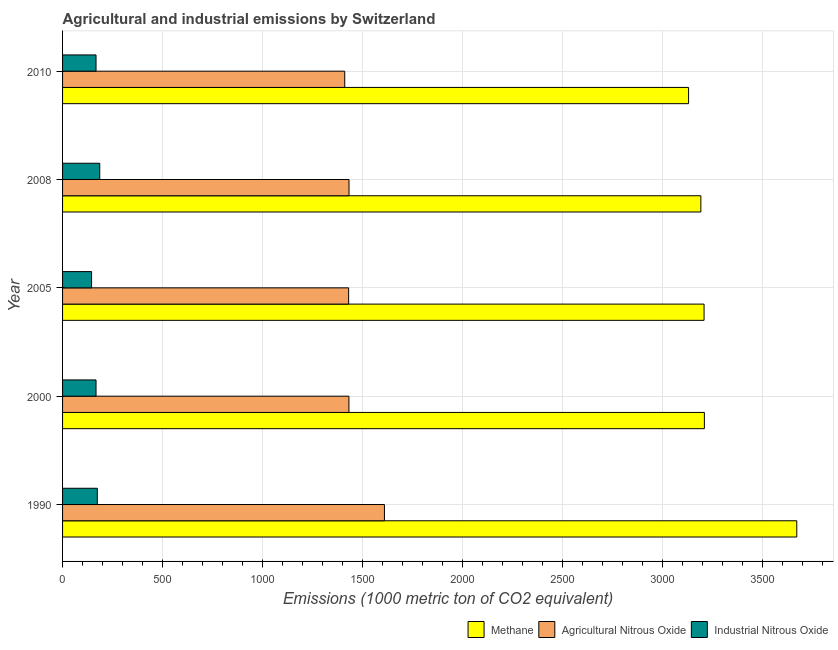How many groups of bars are there?
Keep it short and to the point. 5. How many bars are there on the 4th tick from the top?
Provide a succinct answer. 3. How many bars are there on the 3rd tick from the bottom?
Ensure brevity in your answer.  3. In how many cases, is the number of bars for a given year not equal to the number of legend labels?
Offer a terse response. 0. What is the amount of methane emissions in 2005?
Make the answer very short. 3209.2. Across all years, what is the maximum amount of agricultural nitrous oxide emissions?
Your answer should be very brief. 1610.2. Across all years, what is the minimum amount of methane emissions?
Give a very brief answer. 3131.7. What is the total amount of methane emissions in the graph?
Your answer should be compact. 1.64e+04. What is the difference between the amount of industrial nitrous oxide emissions in 1990 and that in 2005?
Provide a succinct answer. 28.7. What is the difference between the amount of methane emissions in 2000 and the amount of industrial nitrous oxide emissions in 2008?
Give a very brief answer. 3024.7. What is the average amount of industrial nitrous oxide emissions per year?
Keep it short and to the point. 167.94. In the year 2000, what is the difference between the amount of agricultural nitrous oxide emissions and amount of methane emissions?
Keep it short and to the point. -1778.2. Is the amount of methane emissions in 2005 less than that in 2010?
Offer a terse response. No. What is the difference between the highest and the second highest amount of methane emissions?
Your answer should be compact. 462.3. What is the difference between the highest and the lowest amount of agricultural nitrous oxide emissions?
Provide a short and direct response. 198.6. What does the 2nd bar from the top in 2005 represents?
Give a very brief answer. Agricultural Nitrous Oxide. What does the 2nd bar from the bottom in 2005 represents?
Ensure brevity in your answer.  Agricultural Nitrous Oxide. Is it the case that in every year, the sum of the amount of methane emissions and amount of agricultural nitrous oxide emissions is greater than the amount of industrial nitrous oxide emissions?
Ensure brevity in your answer.  Yes. How many bars are there?
Your response must be concise. 15. Are all the bars in the graph horizontal?
Keep it short and to the point. Yes. What is the difference between two consecutive major ticks on the X-axis?
Offer a very short reply. 500. Are the values on the major ticks of X-axis written in scientific E-notation?
Offer a very short reply. No. Where does the legend appear in the graph?
Ensure brevity in your answer.  Bottom right. How many legend labels are there?
Make the answer very short. 3. What is the title of the graph?
Offer a terse response. Agricultural and industrial emissions by Switzerland. What is the label or title of the X-axis?
Keep it short and to the point. Emissions (1000 metric ton of CO2 equivalent). What is the Emissions (1000 metric ton of CO2 equivalent) in Methane in 1990?
Your answer should be compact. 3673. What is the Emissions (1000 metric ton of CO2 equivalent) in Agricultural Nitrous Oxide in 1990?
Ensure brevity in your answer.  1610.2. What is the Emissions (1000 metric ton of CO2 equivalent) in Industrial Nitrous Oxide in 1990?
Give a very brief answer. 173.8. What is the Emissions (1000 metric ton of CO2 equivalent) in Methane in 2000?
Make the answer very short. 3210.7. What is the Emissions (1000 metric ton of CO2 equivalent) of Agricultural Nitrous Oxide in 2000?
Give a very brief answer. 1432.5. What is the Emissions (1000 metric ton of CO2 equivalent) of Industrial Nitrous Oxide in 2000?
Provide a succinct answer. 167.4. What is the Emissions (1000 metric ton of CO2 equivalent) of Methane in 2005?
Ensure brevity in your answer.  3209.2. What is the Emissions (1000 metric ton of CO2 equivalent) in Agricultural Nitrous Oxide in 2005?
Provide a succinct answer. 1431.1. What is the Emissions (1000 metric ton of CO2 equivalent) in Industrial Nitrous Oxide in 2005?
Offer a terse response. 145.1. What is the Emissions (1000 metric ton of CO2 equivalent) of Methane in 2008?
Make the answer very short. 3193.1. What is the Emissions (1000 metric ton of CO2 equivalent) in Agricultural Nitrous Oxide in 2008?
Your answer should be very brief. 1433. What is the Emissions (1000 metric ton of CO2 equivalent) of Industrial Nitrous Oxide in 2008?
Your answer should be compact. 186. What is the Emissions (1000 metric ton of CO2 equivalent) in Methane in 2010?
Your answer should be very brief. 3131.7. What is the Emissions (1000 metric ton of CO2 equivalent) in Agricultural Nitrous Oxide in 2010?
Your response must be concise. 1411.6. What is the Emissions (1000 metric ton of CO2 equivalent) in Industrial Nitrous Oxide in 2010?
Provide a short and direct response. 167.4. Across all years, what is the maximum Emissions (1000 metric ton of CO2 equivalent) of Methane?
Offer a very short reply. 3673. Across all years, what is the maximum Emissions (1000 metric ton of CO2 equivalent) in Agricultural Nitrous Oxide?
Keep it short and to the point. 1610.2. Across all years, what is the maximum Emissions (1000 metric ton of CO2 equivalent) of Industrial Nitrous Oxide?
Your answer should be very brief. 186. Across all years, what is the minimum Emissions (1000 metric ton of CO2 equivalent) of Methane?
Offer a very short reply. 3131.7. Across all years, what is the minimum Emissions (1000 metric ton of CO2 equivalent) of Agricultural Nitrous Oxide?
Provide a succinct answer. 1411.6. Across all years, what is the minimum Emissions (1000 metric ton of CO2 equivalent) in Industrial Nitrous Oxide?
Your answer should be compact. 145.1. What is the total Emissions (1000 metric ton of CO2 equivalent) in Methane in the graph?
Keep it short and to the point. 1.64e+04. What is the total Emissions (1000 metric ton of CO2 equivalent) in Agricultural Nitrous Oxide in the graph?
Your answer should be very brief. 7318.4. What is the total Emissions (1000 metric ton of CO2 equivalent) of Industrial Nitrous Oxide in the graph?
Ensure brevity in your answer.  839.7. What is the difference between the Emissions (1000 metric ton of CO2 equivalent) of Methane in 1990 and that in 2000?
Make the answer very short. 462.3. What is the difference between the Emissions (1000 metric ton of CO2 equivalent) in Agricultural Nitrous Oxide in 1990 and that in 2000?
Your answer should be very brief. 177.7. What is the difference between the Emissions (1000 metric ton of CO2 equivalent) of Methane in 1990 and that in 2005?
Ensure brevity in your answer.  463.8. What is the difference between the Emissions (1000 metric ton of CO2 equivalent) in Agricultural Nitrous Oxide in 1990 and that in 2005?
Provide a succinct answer. 179.1. What is the difference between the Emissions (1000 metric ton of CO2 equivalent) of Industrial Nitrous Oxide in 1990 and that in 2005?
Your answer should be very brief. 28.7. What is the difference between the Emissions (1000 metric ton of CO2 equivalent) of Methane in 1990 and that in 2008?
Ensure brevity in your answer.  479.9. What is the difference between the Emissions (1000 metric ton of CO2 equivalent) of Agricultural Nitrous Oxide in 1990 and that in 2008?
Your answer should be compact. 177.2. What is the difference between the Emissions (1000 metric ton of CO2 equivalent) of Industrial Nitrous Oxide in 1990 and that in 2008?
Ensure brevity in your answer.  -12.2. What is the difference between the Emissions (1000 metric ton of CO2 equivalent) of Methane in 1990 and that in 2010?
Your answer should be very brief. 541.3. What is the difference between the Emissions (1000 metric ton of CO2 equivalent) of Agricultural Nitrous Oxide in 1990 and that in 2010?
Your response must be concise. 198.6. What is the difference between the Emissions (1000 metric ton of CO2 equivalent) of Methane in 2000 and that in 2005?
Ensure brevity in your answer.  1.5. What is the difference between the Emissions (1000 metric ton of CO2 equivalent) in Agricultural Nitrous Oxide in 2000 and that in 2005?
Keep it short and to the point. 1.4. What is the difference between the Emissions (1000 metric ton of CO2 equivalent) in Industrial Nitrous Oxide in 2000 and that in 2005?
Provide a succinct answer. 22.3. What is the difference between the Emissions (1000 metric ton of CO2 equivalent) of Methane in 2000 and that in 2008?
Your answer should be very brief. 17.6. What is the difference between the Emissions (1000 metric ton of CO2 equivalent) in Agricultural Nitrous Oxide in 2000 and that in 2008?
Keep it short and to the point. -0.5. What is the difference between the Emissions (1000 metric ton of CO2 equivalent) of Industrial Nitrous Oxide in 2000 and that in 2008?
Ensure brevity in your answer.  -18.6. What is the difference between the Emissions (1000 metric ton of CO2 equivalent) in Methane in 2000 and that in 2010?
Offer a terse response. 79. What is the difference between the Emissions (1000 metric ton of CO2 equivalent) in Agricultural Nitrous Oxide in 2000 and that in 2010?
Your response must be concise. 20.9. What is the difference between the Emissions (1000 metric ton of CO2 equivalent) in Industrial Nitrous Oxide in 2000 and that in 2010?
Give a very brief answer. 0. What is the difference between the Emissions (1000 metric ton of CO2 equivalent) of Industrial Nitrous Oxide in 2005 and that in 2008?
Ensure brevity in your answer.  -40.9. What is the difference between the Emissions (1000 metric ton of CO2 equivalent) of Methane in 2005 and that in 2010?
Keep it short and to the point. 77.5. What is the difference between the Emissions (1000 metric ton of CO2 equivalent) of Industrial Nitrous Oxide in 2005 and that in 2010?
Keep it short and to the point. -22.3. What is the difference between the Emissions (1000 metric ton of CO2 equivalent) of Methane in 2008 and that in 2010?
Make the answer very short. 61.4. What is the difference between the Emissions (1000 metric ton of CO2 equivalent) in Agricultural Nitrous Oxide in 2008 and that in 2010?
Ensure brevity in your answer.  21.4. What is the difference between the Emissions (1000 metric ton of CO2 equivalent) in Methane in 1990 and the Emissions (1000 metric ton of CO2 equivalent) in Agricultural Nitrous Oxide in 2000?
Your response must be concise. 2240.5. What is the difference between the Emissions (1000 metric ton of CO2 equivalent) of Methane in 1990 and the Emissions (1000 metric ton of CO2 equivalent) of Industrial Nitrous Oxide in 2000?
Ensure brevity in your answer.  3505.6. What is the difference between the Emissions (1000 metric ton of CO2 equivalent) in Agricultural Nitrous Oxide in 1990 and the Emissions (1000 metric ton of CO2 equivalent) in Industrial Nitrous Oxide in 2000?
Provide a short and direct response. 1442.8. What is the difference between the Emissions (1000 metric ton of CO2 equivalent) of Methane in 1990 and the Emissions (1000 metric ton of CO2 equivalent) of Agricultural Nitrous Oxide in 2005?
Offer a terse response. 2241.9. What is the difference between the Emissions (1000 metric ton of CO2 equivalent) in Methane in 1990 and the Emissions (1000 metric ton of CO2 equivalent) in Industrial Nitrous Oxide in 2005?
Your answer should be compact. 3527.9. What is the difference between the Emissions (1000 metric ton of CO2 equivalent) of Agricultural Nitrous Oxide in 1990 and the Emissions (1000 metric ton of CO2 equivalent) of Industrial Nitrous Oxide in 2005?
Offer a terse response. 1465.1. What is the difference between the Emissions (1000 metric ton of CO2 equivalent) in Methane in 1990 and the Emissions (1000 metric ton of CO2 equivalent) in Agricultural Nitrous Oxide in 2008?
Give a very brief answer. 2240. What is the difference between the Emissions (1000 metric ton of CO2 equivalent) of Methane in 1990 and the Emissions (1000 metric ton of CO2 equivalent) of Industrial Nitrous Oxide in 2008?
Offer a terse response. 3487. What is the difference between the Emissions (1000 metric ton of CO2 equivalent) in Agricultural Nitrous Oxide in 1990 and the Emissions (1000 metric ton of CO2 equivalent) in Industrial Nitrous Oxide in 2008?
Provide a short and direct response. 1424.2. What is the difference between the Emissions (1000 metric ton of CO2 equivalent) of Methane in 1990 and the Emissions (1000 metric ton of CO2 equivalent) of Agricultural Nitrous Oxide in 2010?
Your answer should be compact. 2261.4. What is the difference between the Emissions (1000 metric ton of CO2 equivalent) in Methane in 1990 and the Emissions (1000 metric ton of CO2 equivalent) in Industrial Nitrous Oxide in 2010?
Your answer should be very brief. 3505.6. What is the difference between the Emissions (1000 metric ton of CO2 equivalent) in Agricultural Nitrous Oxide in 1990 and the Emissions (1000 metric ton of CO2 equivalent) in Industrial Nitrous Oxide in 2010?
Give a very brief answer. 1442.8. What is the difference between the Emissions (1000 metric ton of CO2 equivalent) of Methane in 2000 and the Emissions (1000 metric ton of CO2 equivalent) of Agricultural Nitrous Oxide in 2005?
Keep it short and to the point. 1779.6. What is the difference between the Emissions (1000 metric ton of CO2 equivalent) of Methane in 2000 and the Emissions (1000 metric ton of CO2 equivalent) of Industrial Nitrous Oxide in 2005?
Offer a terse response. 3065.6. What is the difference between the Emissions (1000 metric ton of CO2 equivalent) in Agricultural Nitrous Oxide in 2000 and the Emissions (1000 metric ton of CO2 equivalent) in Industrial Nitrous Oxide in 2005?
Offer a terse response. 1287.4. What is the difference between the Emissions (1000 metric ton of CO2 equivalent) in Methane in 2000 and the Emissions (1000 metric ton of CO2 equivalent) in Agricultural Nitrous Oxide in 2008?
Ensure brevity in your answer.  1777.7. What is the difference between the Emissions (1000 metric ton of CO2 equivalent) in Methane in 2000 and the Emissions (1000 metric ton of CO2 equivalent) in Industrial Nitrous Oxide in 2008?
Your response must be concise. 3024.7. What is the difference between the Emissions (1000 metric ton of CO2 equivalent) of Agricultural Nitrous Oxide in 2000 and the Emissions (1000 metric ton of CO2 equivalent) of Industrial Nitrous Oxide in 2008?
Provide a succinct answer. 1246.5. What is the difference between the Emissions (1000 metric ton of CO2 equivalent) in Methane in 2000 and the Emissions (1000 metric ton of CO2 equivalent) in Agricultural Nitrous Oxide in 2010?
Provide a succinct answer. 1799.1. What is the difference between the Emissions (1000 metric ton of CO2 equivalent) of Methane in 2000 and the Emissions (1000 metric ton of CO2 equivalent) of Industrial Nitrous Oxide in 2010?
Provide a short and direct response. 3043.3. What is the difference between the Emissions (1000 metric ton of CO2 equivalent) in Agricultural Nitrous Oxide in 2000 and the Emissions (1000 metric ton of CO2 equivalent) in Industrial Nitrous Oxide in 2010?
Provide a succinct answer. 1265.1. What is the difference between the Emissions (1000 metric ton of CO2 equivalent) in Methane in 2005 and the Emissions (1000 metric ton of CO2 equivalent) in Agricultural Nitrous Oxide in 2008?
Provide a short and direct response. 1776.2. What is the difference between the Emissions (1000 metric ton of CO2 equivalent) of Methane in 2005 and the Emissions (1000 metric ton of CO2 equivalent) of Industrial Nitrous Oxide in 2008?
Keep it short and to the point. 3023.2. What is the difference between the Emissions (1000 metric ton of CO2 equivalent) of Agricultural Nitrous Oxide in 2005 and the Emissions (1000 metric ton of CO2 equivalent) of Industrial Nitrous Oxide in 2008?
Your answer should be compact. 1245.1. What is the difference between the Emissions (1000 metric ton of CO2 equivalent) in Methane in 2005 and the Emissions (1000 metric ton of CO2 equivalent) in Agricultural Nitrous Oxide in 2010?
Offer a terse response. 1797.6. What is the difference between the Emissions (1000 metric ton of CO2 equivalent) in Methane in 2005 and the Emissions (1000 metric ton of CO2 equivalent) in Industrial Nitrous Oxide in 2010?
Your answer should be compact. 3041.8. What is the difference between the Emissions (1000 metric ton of CO2 equivalent) in Agricultural Nitrous Oxide in 2005 and the Emissions (1000 metric ton of CO2 equivalent) in Industrial Nitrous Oxide in 2010?
Your answer should be compact. 1263.7. What is the difference between the Emissions (1000 metric ton of CO2 equivalent) in Methane in 2008 and the Emissions (1000 metric ton of CO2 equivalent) in Agricultural Nitrous Oxide in 2010?
Your answer should be very brief. 1781.5. What is the difference between the Emissions (1000 metric ton of CO2 equivalent) of Methane in 2008 and the Emissions (1000 metric ton of CO2 equivalent) of Industrial Nitrous Oxide in 2010?
Your answer should be very brief. 3025.7. What is the difference between the Emissions (1000 metric ton of CO2 equivalent) of Agricultural Nitrous Oxide in 2008 and the Emissions (1000 metric ton of CO2 equivalent) of Industrial Nitrous Oxide in 2010?
Make the answer very short. 1265.6. What is the average Emissions (1000 metric ton of CO2 equivalent) of Methane per year?
Your answer should be compact. 3283.54. What is the average Emissions (1000 metric ton of CO2 equivalent) of Agricultural Nitrous Oxide per year?
Offer a terse response. 1463.68. What is the average Emissions (1000 metric ton of CO2 equivalent) in Industrial Nitrous Oxide per year?
Offer a terse response. 167.94. In the year 1990, what is the difference between the Emissions (1000 metric ton of CO2 equivalent) in Methane and Emissions (1000 metric ton of CO2 equivalent) in Agricultural Nitrous Oxide?
Offer a very short reply. 2062.8. In the year 1990, what is the difference between the Emissions (1000 metric ton of CO2 equivalent) in Methane and Emissions (1000 metric ton of CO2 equivalent) in Industrial Nitrous Oxide?
Offer a terse response. 3499.2. In the year 1990, what is the difference between the Emissions (1000 metric ton of CO2 equivalent) of Agricultural Nitrous Oxide and Emissions (1000 metric ton of CO2 equivalent) of Industrial Nitrous Oxide?
Make the answer very short. 1436.4. In the year 2000, what is the difference between the Emissions (1000 metric ton of CO2 equivalent) of Methane and Emissions (1000 metric ton of CO2 equivalent) of Agricultural Nitrous Oxide?
Provide a short and direct response. 1778.2. In the year 2000, what is the difference between the Emissions (1000 metric ton of CO2 equivalent) in Methane and Emissions (1000 metric ton of CO2 equivalent) in Industrial Nitrous Oxide?
Keep it short and to the point. 3043.3. In the year 2000, what is the difference between the Emissions (1000 metric ton of CO2 equivalent) of Agricultural Nitrous Oxide and Emissions (1000 metric ton of CO2 equivalent) of Industrial Nitrous Oxide?
Your response must be concise. 1265.1. In the year 2005, what is the difference between the Emissions (1000 metric ton of CO2 equivalent) in Methane and Emissions (1000 metric ton of CO2 equivalent) in Agricultural Nitrous Oxide?
Provide a short and direct response. 1778.1. In the year 2005, what is the difference between the Emissions (1000 metric ton of CO2 equivalent) of Methane and Emissions (1000 metric ton of CO2 equivalent) of Industrial Nitrous Oxide?
Offer a very short reply. 3064.1. In the year 2005, what is the difference between the Emissions (1000 metric ton of CO2 equivalent) of Agricultural Nitrous Oxide and Emissions (1000 metric ton of CO2 equivalent) of Industrial Nitrous Oxide?
Ensure brevity in your answer.  1286. In the year 2008, what is the difference between the Emissions (1000 metric ton of CO2 equivalent) of Methane and Emissions (1000 metric ton of CO2 equivalent) of Agricultural Nitrous Oxide?
Ensure brevity in your answer.  1760.1. In the year 2008, what is the difference between the Emissions (1000 metric ton of CO2 equivalent) in Methane and Emissions (1000 metric ton of CO2 equivalent) in Industrial Nitrous Oxide?
Your response must be concise. 3007.1. In the year 2008, what is the difference between the Emissions (1000 metric ton of CO2 equivalent) of Agricultural Nitrous Oxide and Emissions (1000 metric ton of CO2 equivalent) of Industrial Nitrous Oxide?
Your answer should be compact. 1247. In the year 2010, what is the difference between the Emissions (1000 metric ton of CO2 equivalent) in Methane and Emissions (1000 metric ton of CO2 equivalent) in Agricultural Nitrous Oxide?
Give a very brief answer. 1720.1. In the year 2010, what is the difference between the Emissions (1000 metric ton of CO2 equivalent) of Methane and Emissions (1000 metric ton of CO2 equivalent) of Industrial Nitrous Oxide?
Keep it short and to the point. 2964.3. In the year 2010, what is the difference between the Emissions (1000 metric ton of CO2 equivalent) in Agricultural Nitrous Oxide and Emissions (1000 metric ton of CO2 equivalent) in Industrial Nitrous Oxide?
Offer a terse response. 1244.2. What is the ratio of the Emissions (1000 metric ton of CO2 equivalent) in Methane in 1990 to that in 2000?
Offer a terse response. 1.14. What is the ratio of the Emissions (1000 metric ton of CO2 equivalent) in Agricultural Nitrous Oxide in 1990 to that in 2000?
Offer a terse response. 1.12. What is the ratio of the Emissions (1000 metric ton of CO2 equivalent) in Industrial Nitrous Oxide in 1990 to that in 2000?
Give a very brief answer. 1.04. What is the ratio of the Emissions (1000 metric ton of CO2 equivalent) in Methane in 1990 to that in 2005?
Your answer should be compact. 1.14. What is the ratio of the Emissions (1000 metric ton of CO2 equivalent) in Agricultural Nitrous Oxide in 1990 to that in 2005?
Provide a short and direct response. 1.13. What is the ratio of the Emissions (1000 metric ton of CO2 equivalent) in Industrial Nitrous Oxide in 1990 to that in 2005?
Provide a short and direct response. 1.2. What is the ratio of the Emissions (1000 metric ton of CO2 equivalent) in Methane in 1990 to that in 2008?
Provide a succinct answer. 1.15. What is the ratio of the Emissions (1000 metric ton of CO2 equivalent) in Agricultural Nitrous Oxide in 1990 to that in 2008?
Provide a succinct answer. 1.12. What is the ratio of the Emissions (1000 metric ton of CO2 equivalent) in Industrial Nitrous Oxide in 1990 to that in 2008?
Give a very brief answer. 0.93. What is the ratio of the Emissions (1000 metric ton of CO2 equivalent) of Methane in 1990 to that in 2010?
Give a very brief answer. 1.17. What is the ratio of the Emissions (1000 metric ton of CO2 equivalent) of Agricultural Nitrous Oxide in 1990 to that in 2010?
Offer a terse response. 1.14. What is the ratio of the Emissions (1000 metric ton of CO2 equivalent) of Industrial Nitrous Oxide in 1990 to that in 2010?
Give a very brief answer. 1.04. What is the ratio of the Emissions (1000 metric ton of CO2 equivalent) of Agricultural Nitrous Oxide in 2000 to that in 2005?
Ensure brevity in your answer.  1. What is the ratio of the Emissions (1000 metric ton of CO2 equivalent) in Industrial Nitrous Oxide in 2000 to that in 2005?
Keep it short and to the point. 1.15. What is the ratio of the Emissions (1000 metric ton of CO2 equivalent) in Methane in 2000 to that in 2008?
Ensure brevity in your answer.  1.01. What is the ratio of the Emissions (1000 metric ton of CO2 equivalent) in Agricultural Nitrous Oxide in 2000 to that in 2008?
Give a very brief answer. 1. What is the ratio of the Emissions (1000 metric ton of CO2 equivalent) of Methane in 2000 to that in 2010?
Provide a short and direct response. 1.03. What is the ratio of the Emissions (1000 metric ton of CO2 equivalent) in Agricultural Nitrous Oxide in 2000 to that in 2010?
Provide a succinct answer. 1.01. What is the ratio of the Emissions (1000 metric ton of CO2 equivalent) of Industrial Nitrous Oxide in 2000 to that in 2010?
Provide a succinct answer. 1. What is the ratio of the Emissions (1000 metric ton of CO2 equivalent) in Methane in 2005 to that in 2008?
Make the answer very short. 1. What is the ratio of the Emissions (1000 metric ton of CO2 equivalent) of Agricultural Nitrous Oxide in 2005 to that in 2008?
Provide a short and direct response. 1. What is the ratio of the Emissions (1000 metric ton of CO2 equivalent) in Industrial Nitrous Oxide in 2005 to that in 2008?
Keep it short and to the point. 0.78. What is the ratio of the Emissions (1000 metric ton of CO2 equivalent) in Methane in 2005 to that in 2010?
Provide a succinct answer. 1.02. What is the ratio of the Emissions (1000 metric ton of CO2 equivalent) of Agricultural Nitrous Oxide in 2005 to that in 2010?
Provide a succinct answer. 1.01. What is the ratio of the Emissions (1000 metric ton of CO2 equivalent) of Industrial Nitrous Oxide in 2005 to that in 2010?
Ensure brevity in your answer.  0.87. What is the ratio of the Emissions (1000 metric ton of CO2 equivalent) of Methane in 2008 to that in 2010?
Give a very brief answer. 1.02. What is the ratio of the Emissions (1000 metric ton of CO2 equivalent) of Agricultural Nitrous Oxide in 2008 to that in 2010?
Provide a succinct answer. 1.02. What is the ratio of the Emissions (1000 metric ton of CO2 equivalent) in Industrial Nitrous Oxide in 2008 to that in 2010?
Your answer should be compact. 1.11. What is the difference between the highest and the second highest Emissions (1000 metric ton of CO2 equivalent) in Methane?
Give a very brief answer. 462.3. What is the difference between the highest and the second highest Emissions (1000 metric ton of CO2 equivalent) in Agricultural Nitrous Oxide?
Keep it short and to the point. 177.2. What is the difference between the highest and the second highest Emissions (1000 metric ton of CO2 equivalent) of Industrial Nitrous Oxide?
Give a very brief answer. 12.2. What is the difference between the highest and the lowest Emissions (1000 metric ton of CO2 equivalent) in Methane?
Give a very brief answer. 541.3. What is the difference between the highest and the lowest Emissions (1000 metric ton of CO2 equivalent) in Agricultural Nitrous Oxide?
Provide a succinct answer. 198.6. What is the difference between the highest and the lowest Emissions (1000 metric ton of CO2 equivalent) in Industrial Nitrous Oxide?
Keep it short and to the point. 40.9. 